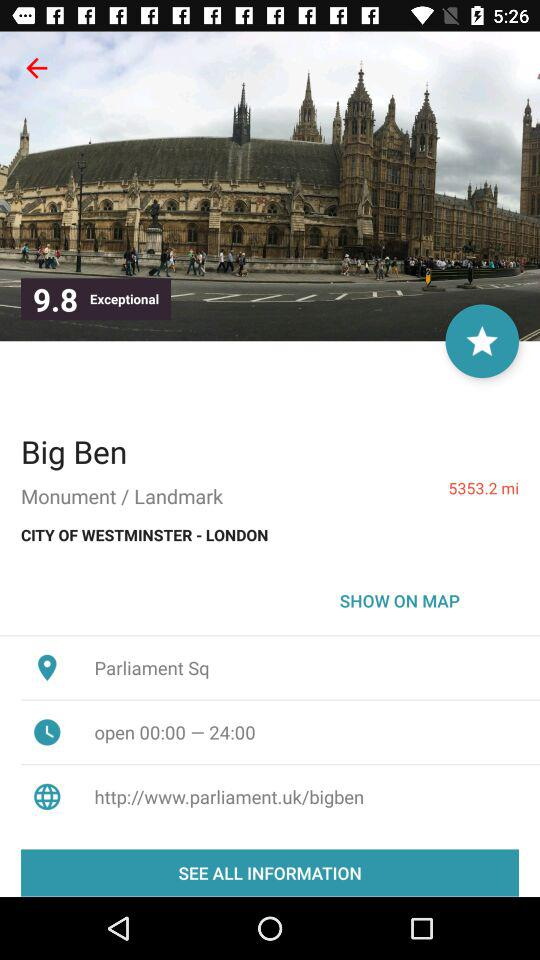What is the distance to the location of Big Ben?
Answer the question using a single word or phrase. 5353.2 mi 